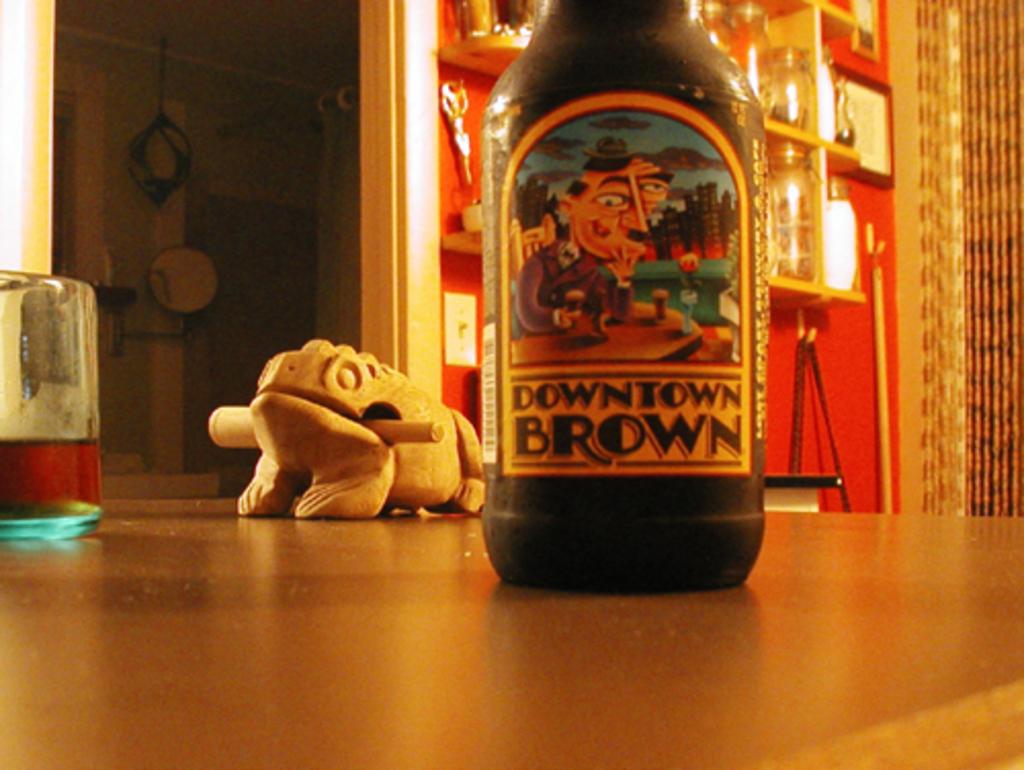Is downtown brown a kind of beer?
Your answer should be compact. Yes. What brand of beer?
Give a very brief answer. Downtown brown. 